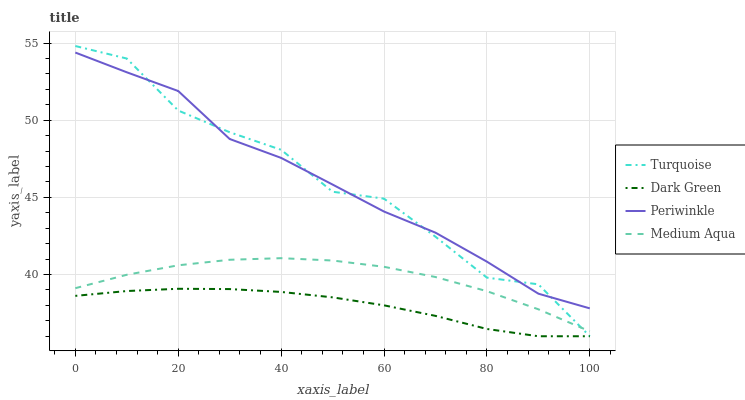Does Dark Green have the minimum area under the curve?
Answer yes or no. Yes. Does Periwinkle have the maximum area under the curve?
Answer yes or no. Yes. Does Turquoise have the minimum area under the curve?
Answer yes or no. No. Does Turquoise have the maximum area under the curve?
Answer yes or no. No. Is Dark Green the smoothest?
Answer yes or no. Yes. Is Turquoise the roughest?
Answer yes or no. Yes. Is Periwinkle the smoothest?
Answer yes or no. No. Is Periwinkle the roughest?
Answer yes or no. No. Does Turquoise have the lowest value?
Answer yes or no. Yes. Does Periwinkle have the lowest value?
Answer yes or no. No. Does Turquoise have the highest value?
Answer yes or no. Yes. Does Periwinkle have the highest value?
Answer yes or no. No. Is Dark Green less than Medium Aqua?
Answer yes or no. Yes. Is Periwinkle greater than Dark Green?
Answer yes or no. Yes. Does Turquoise intersect Periwinkle?
Answer yes or no. Yes. Is Turquoise less than Periwinkle?
Answer yes or no. No. Is Turquoise greater than Periwinkle?
Answer yes or no. No. Does Dark Green intersect Medium Aqua?
Answer yes or no. No. 